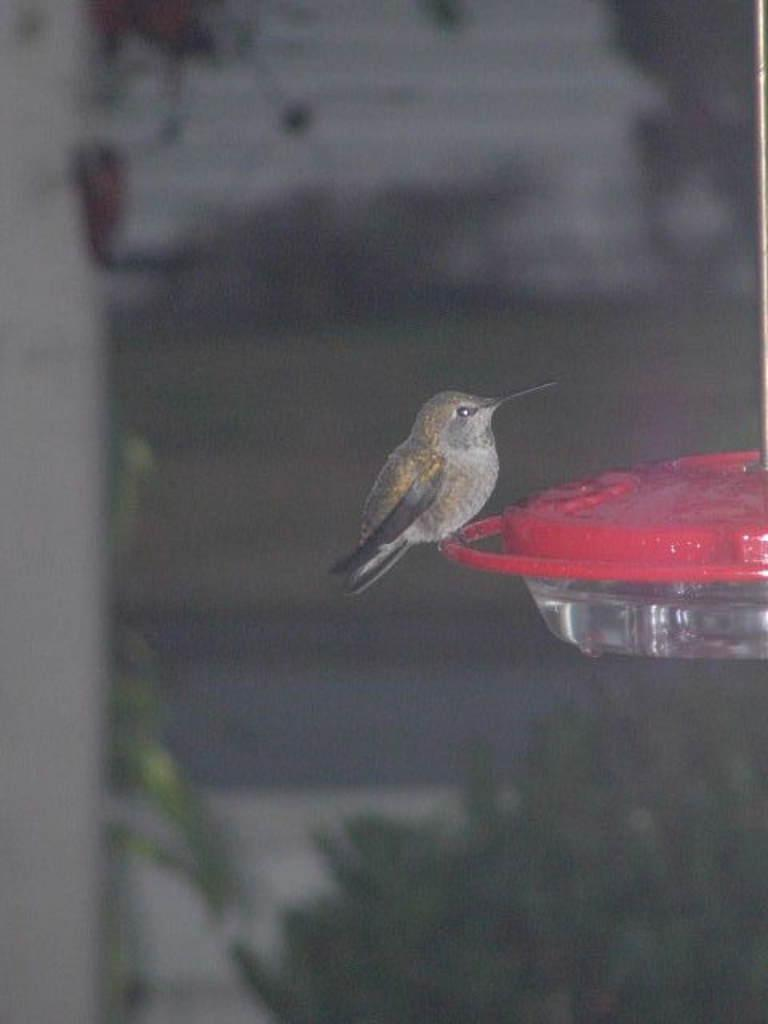What type of bird is in the image? There is a sparrow in the image. What can be seen on the right side of the image? There is an object with water on the right side of the image. Can you describe the background of the image? The background of the image is blurred. What type of stem can be seen growing from the sparrow's head in the image? There is no stem growing from the sparrow's head in the image. Is there a bear visible in the image? No, there is no bear present in the image. 